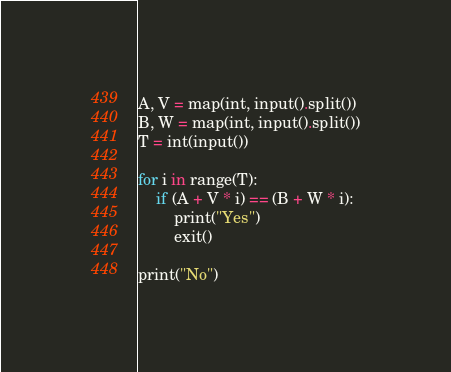Convert code to text. <code><loc_0><loc_0><loc_500><loc_500><_Python_>A, V = map(int, input().split())
B, W = map(int, input().split())
T = int(input())

for i in range(T):
    if (A + V * i) == (B + W * i):
        print("Yes")
        exit()

print("No")</code> 